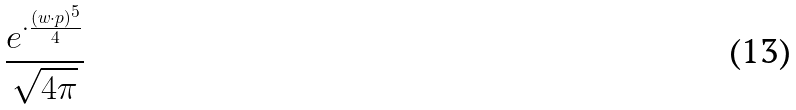<formula> <loc_0><loc_0><loc_500><loc_500>\frac { e ^ { \cdot \frac { ( w \cdot p ) ^ { 5 } } { 4 } } } { \sqrt { 4 \pi } }</formula> 